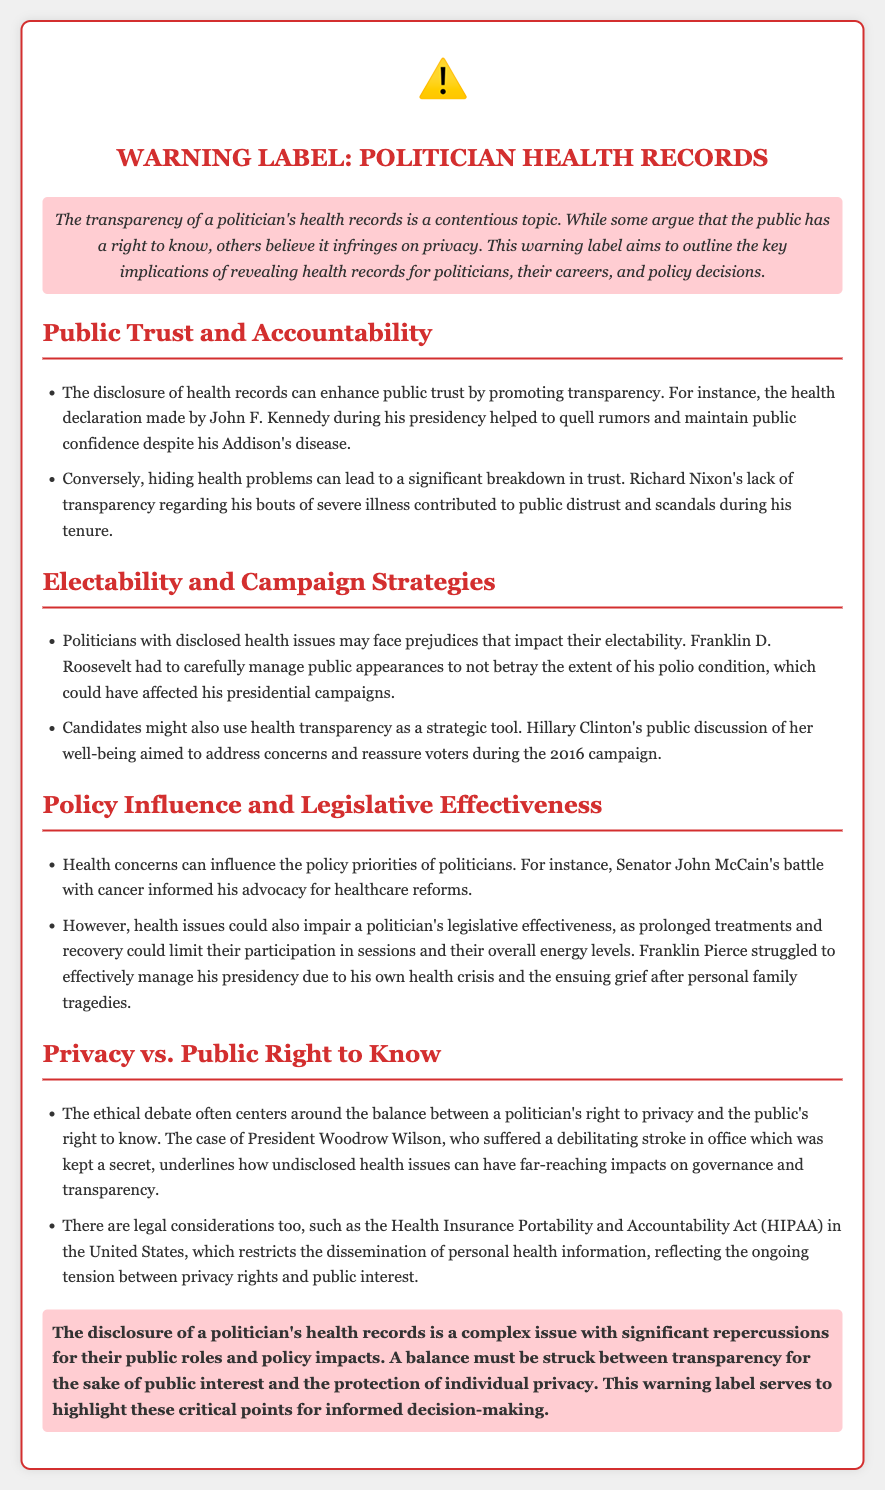What is the title of the document? The title of the document is displayed prominently and indicates its subject matter, focusing on health records and politicians.
Answer: Warning Label: Politician Health Records Which U.S. president's health declaration is mentioned? The document references a significant health declaration made by a president, which had an impact on public trust.
Answer: John F. Kennedy What health condition affected Franklin D. Roosevelt? The document highlights the health challenge Franklin D. Roosevelt faced that required careful management during his campaigns.
Answer: Polio What primary concern does the case of President Woodrow Wilson illustrate? The document underscores the potential consequences of undisclosed health issues on governance.
Answer: Governance and transparency Which act is mentioned regarding the dissemination of health information? The document refers to a specific legal act that protects personal health information, affecting politicians and their privacy.
Answer: Health Insurance Portability and Accountability Act (HIPAA) How can health concerns influence a politician's advocacy? The document explains that health issues can shape the priorities and advocacy efforts of politicians, providing a specific example.
Answer: Healthcare reforms What is one potential impact of a politician's prolonged health treatment? The document outlines a drawback of health issues affecting a politician's participation and performance in their role.
Answer: Legislative effectiveness What color is the warning label's border? The styling of the document highlights the color used for the border of the warning label, reinforcing its significance.
Answer: Dark red 